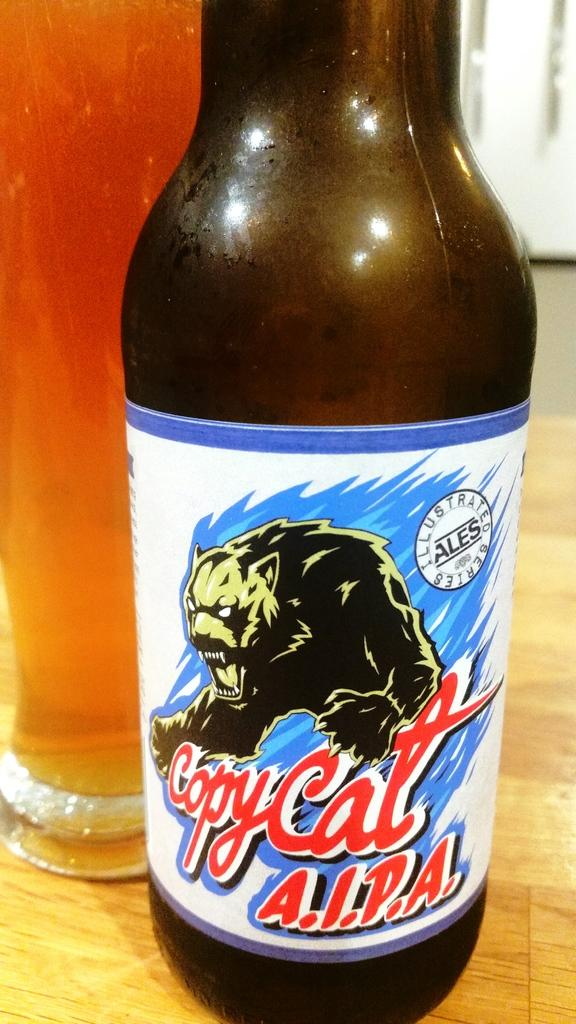<image>
Describe the image concisely. An angry werewolf is depicted on a bottle of Copycat A.I.P.A. 